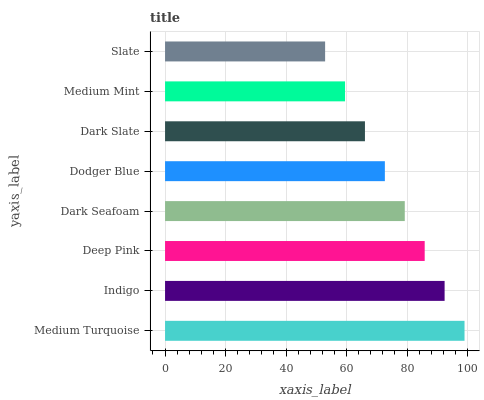Is Slate the minimum?
Answer yes or no. Yes. Is Medium Turquoise the maximum?
Answer yes or no. Yes. Is Indigo the minimum?
Answer yes or no. No. Is Indigo the maximum?
Answer yes or no. No. Is Medium Turquoise greater than Indigo?
Answer yes or no. Yes. Is Indigo less than Medium Turquoise?
Answer yes or no. Yes. Is Indigo greater than Medium Turquoise?
Answer yes or no. No. Is Medium Turquoise less than Indigo?
Answer yes or no. No. Is Dark Seafoam the high median?
Answer yes or no. Yes. Is Dodger Blue the low median?
Answer yes or no. Yes. Is Deep Pink the high median?
Answer yes or no. No. Is Medium Turquoise the low median?
Answer yes or no. No. 